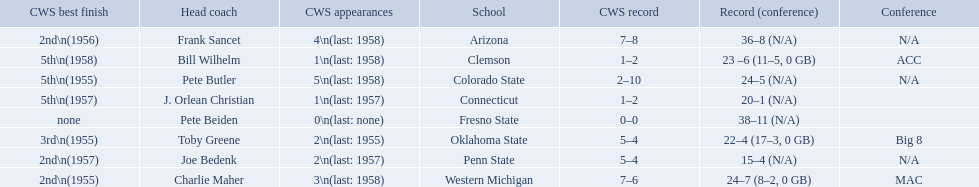What are the teams in the conference? Arizona, Clemson, Colorado State, Connecticut, Fresno State, Oklahoma State, Penn State, Western Michigan. Which have more than 16 wins? Arizona, Clemson, Colorado State, Connecticut, Fresno State, Oklahoma State, Western Michigan. Which had less than 16 wins? Penn State. How many cws appearances does clemson have? 1\n(last: 1958). How many cws appearances does western michigan have? 3\n(last: 1958). Which of these schools has more cws appearances? Western Michigan. What are the listed schools? Arizona, Clemson, Colorado State, Connecticut, Fresno State, Oklahoma State, Penn State, Western Michigan. Which are clemson and western michigan? Clemson, Western Michigan. What are their corresponding numbers of cws appearances? 1\n(last: 1958), 3\n(last: 1958). Which value is larger? 3\n(last: 1958). To which school does that value belong to? Western Michigan. What were scores for each school in the 1959 ncaa tournament? 36–8 (N/A), 23 –6 (11–5, 0 GB), 24–5 (N/A), 20–1 (N/A), 38–11 (N/A), 22–4 (17–3, 0 GB), 15–4 (N/A), 24–7 (8–2, 0 GB). What score did not have at least 16 wins? 15–4 (N/A). What team earned this score? Penn State. 